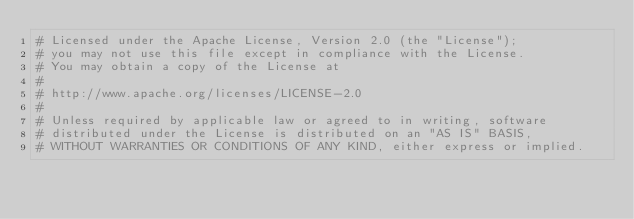<code> <loc_0><loc_0><loc_500><loc_500><_Python_># Licensed under the Apache License, Version 2.0 (the "License");
# you may not use this file except in compliance with the License.
# You may obtain a copy of the License at
#
# http://www.apache.org/licenses/LICENSE-2.0
#
# Unless required by applicable law or agreed to in writing, software
# distributed under the License is distributed on an "AS IS" BASIS,
# WITHOUT WARRANTIES OR CONDITIONS OF ANY KIND, either express or implied.</code> 